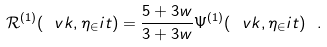Convert formula to latex. <formula><loc_0><loc_0><loc_500><loc_500>\mathcal { R } ^ { ( 1 ) } ( \ v k , \eta _ { \in } i t ) = \frac { 5 + 3 w } { 3 + 3 w } \Psi ^ { ( 1 ) } ( \ v k , \eta _ { \in } i t ) \ .</formula> 